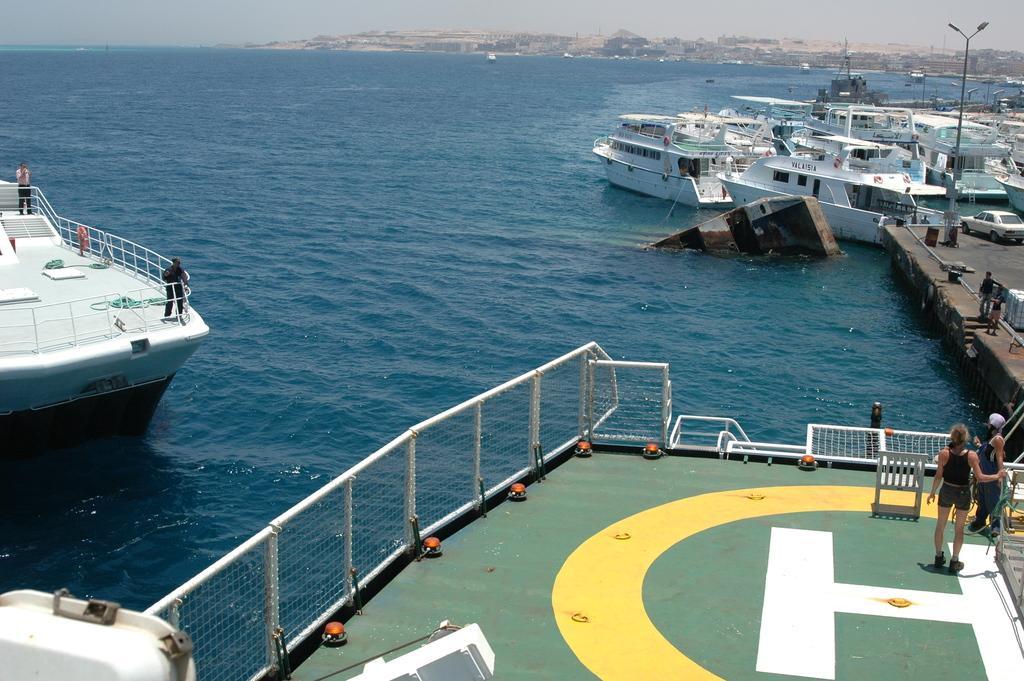How would you summarize this image in a sentence or two? In this picture we can see some white boats on the sea water. In the front bottom side there is a cruise with green helipad made on it. On the top there are two women standing and looking straight. In the background we can see water and some buildings. 